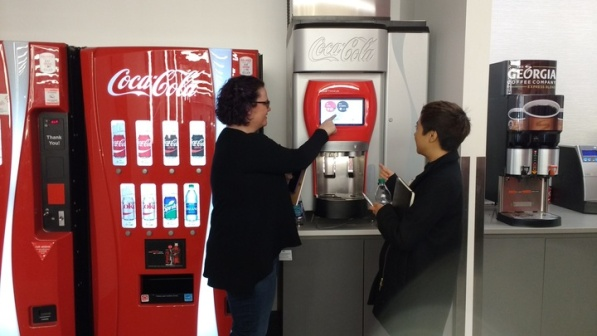What is this photo about? The photo captures a moment between a woman and a young boy in a room with two distinct Coca-Cola vending machines. On the left, the woman, with her casual attire and a supportive stance, interacts with a modern touch screen Coca-Cola vending machine, showcasing the latest digital technology in consumer products. Meanwhile, the boy on the right seems captivated by an older, button-operated machine that also offers Georgia Coffee, demonstrating a blend of traditional and modern vending technology in a single setting. The contrast in their focus not only highlights the generational technology shift but also subtly hints at the different interests and behaviors among age groups when approaching technology. The clean and simple backdrop of the room accentuates their interaction, making the image a clear depiction of everyday technology usage and its evolution in public spaces. 